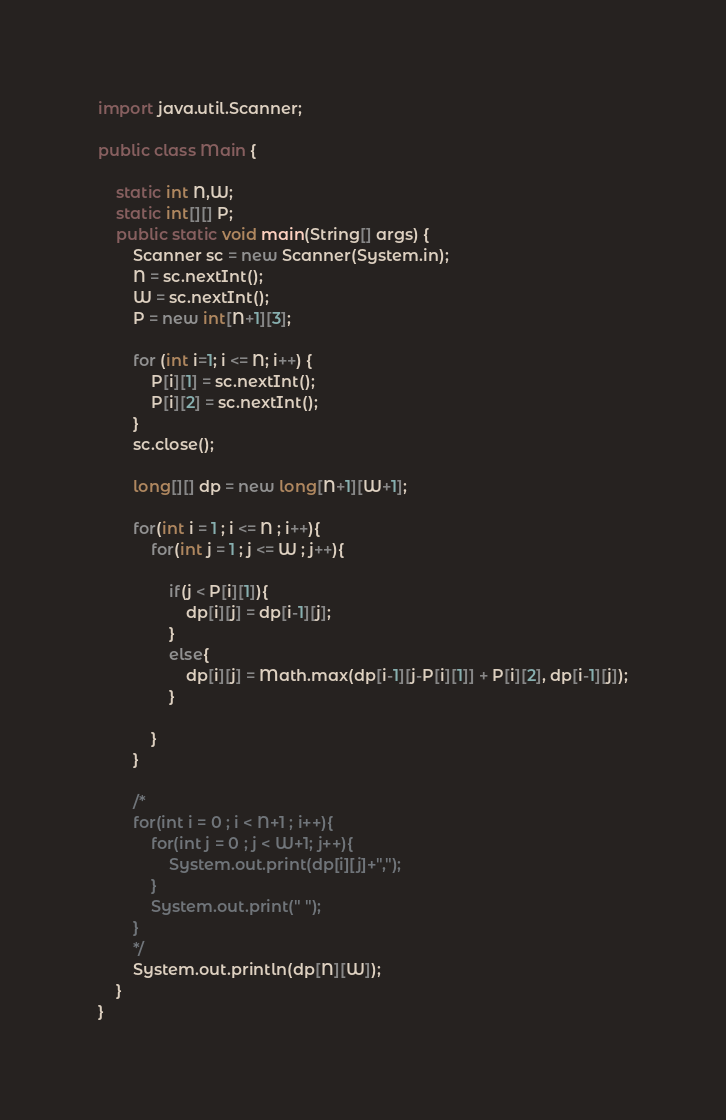<code> <loc_0><loc_0><loc_500><loc_500><_Java_>import java.util.Scanner;

public class Main {

	static int N,W;
	static int[][] P;
	public static void main(String[] args) {
		Scanner sc = new Scanner(System.in);
		N = sc.nextInt();
		W = sc.nextInt();
		P = new int[N+1][3];

		for (int i=1; i <= N; i++) {
			P[i][1] = sc.nextInt();
			P[i][2] = sc.nextInt();
		}
		sc.close();

		long[][] dp = new long[N+1][W+1];

		for(int i = 1 ; i <= N ; i++){
			for(int j = 1 ; j <= W ; j++){

				if(j < P[i][1]){
					dp[i][j] = dp[i-1][j];
				}
				else{
					dp[i][j] = Math.max(dp[i-1][j-P[i][1]] + P[i][2], dp[i-1][j]);
				}

			}
		}

		/*
		for(int i = 0 ; i < N+1 ; i++){
			for(int j = 0 ; j < W+1; j++){
				System.out.print(dp[i][j]+",");
			}
			System.out.print(" ");
		}
		*/
		System.out.println(dp[N][W]);
	}
}
</code> 